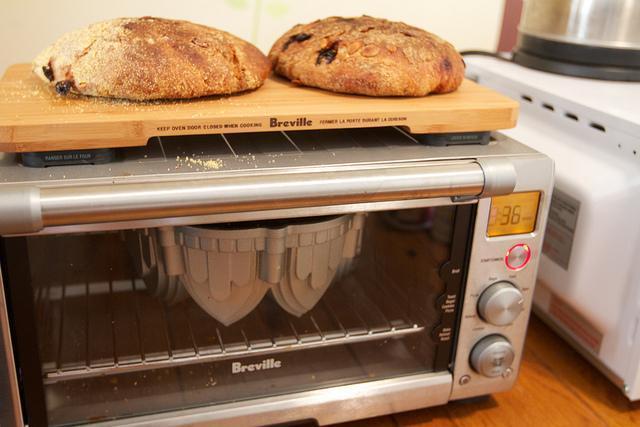How many knobs are pictured?
Give a very brief answer. 2. How many cakes are there?
Give a very brief answer. 2. How many microwaves are there?
Give a very brief answer. 1. How many donuts are there?
Give a very brief answer. 0. 